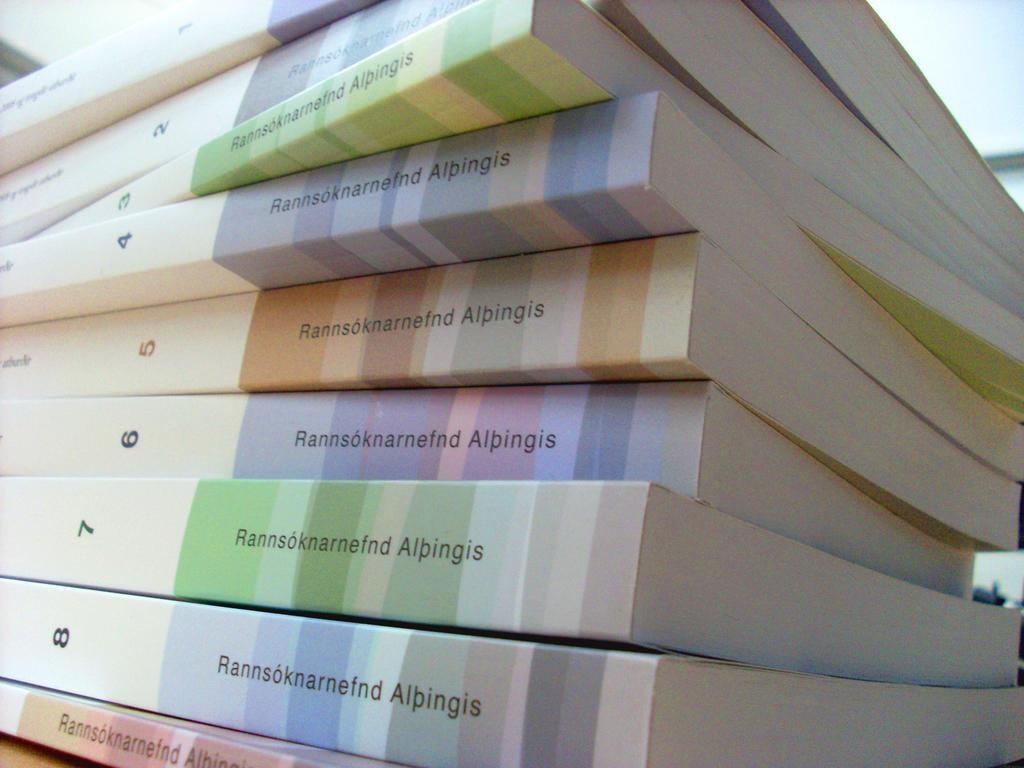Provide a one-sentence caption for the provided image. A stack of books numbered from 1 through 8 from Rannsoknarnefnd Albingis. 